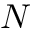<formula> <loc_0><loc_0><loc_500><loc_500>N</formula> 